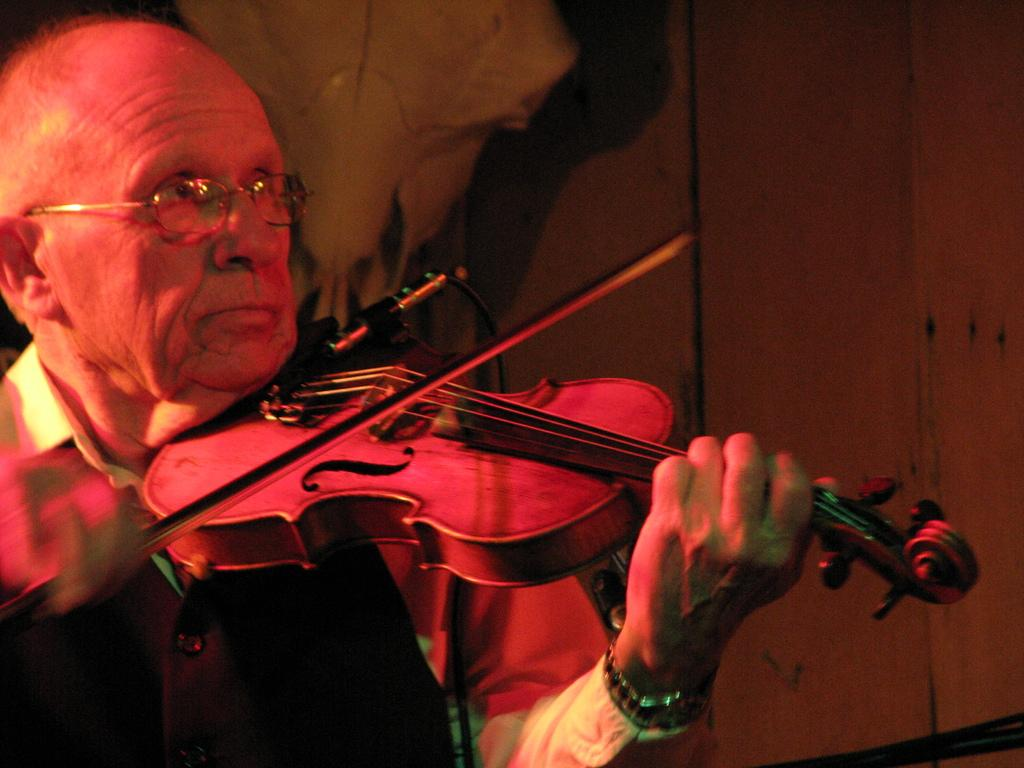What is the main subject of the image? The main subject of the image is a man. What is the man doing in the image? The man is playing a violin in the image. What type of porter is assisting the man in the image? There is no porter present in the image; it only features a man playing a violin. 